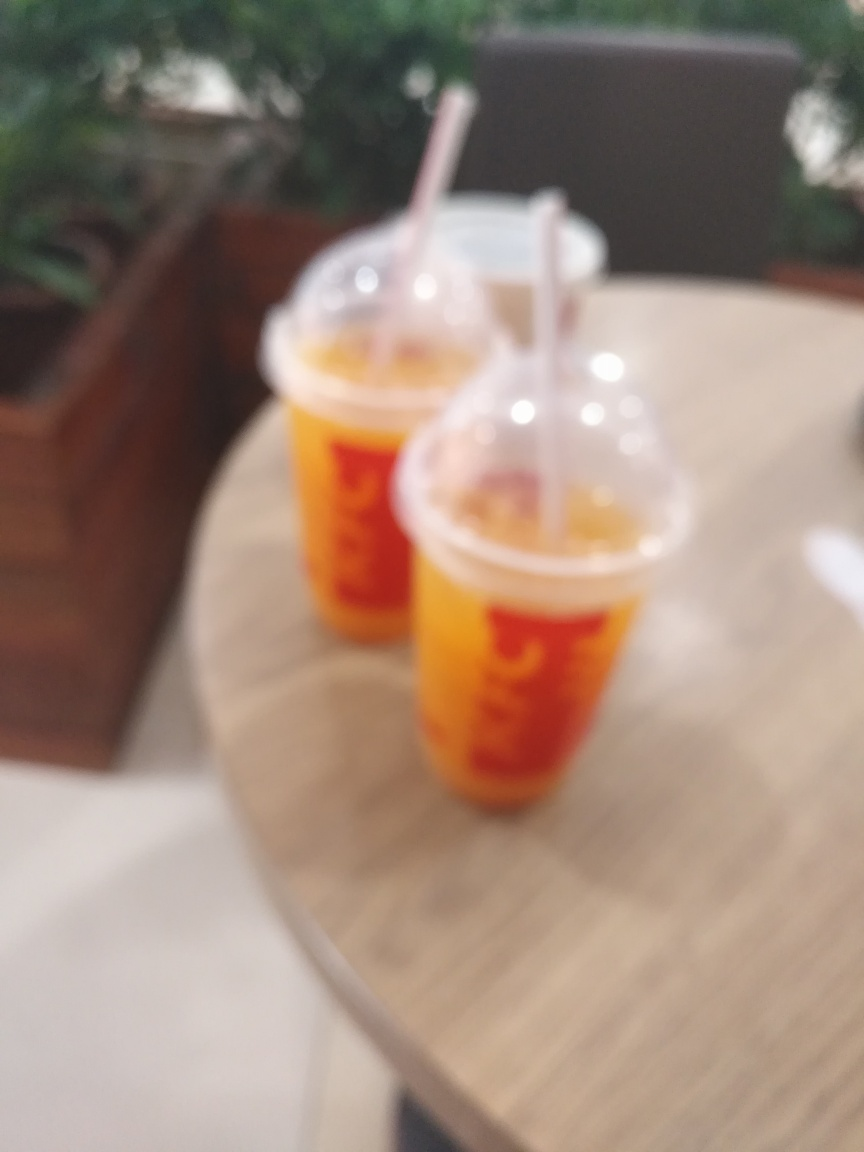Can you describe the setting in which these objects are placed? The objects, which appear to be two cups, are situated on a flat surface indicative of a table, set against a background that suggests an indoor environment possibly a cafe or a casual dining area. The exact details of the setting are indiscernible due to the image's focus, rendering the specifics of the location and surrounding elements blurry. 